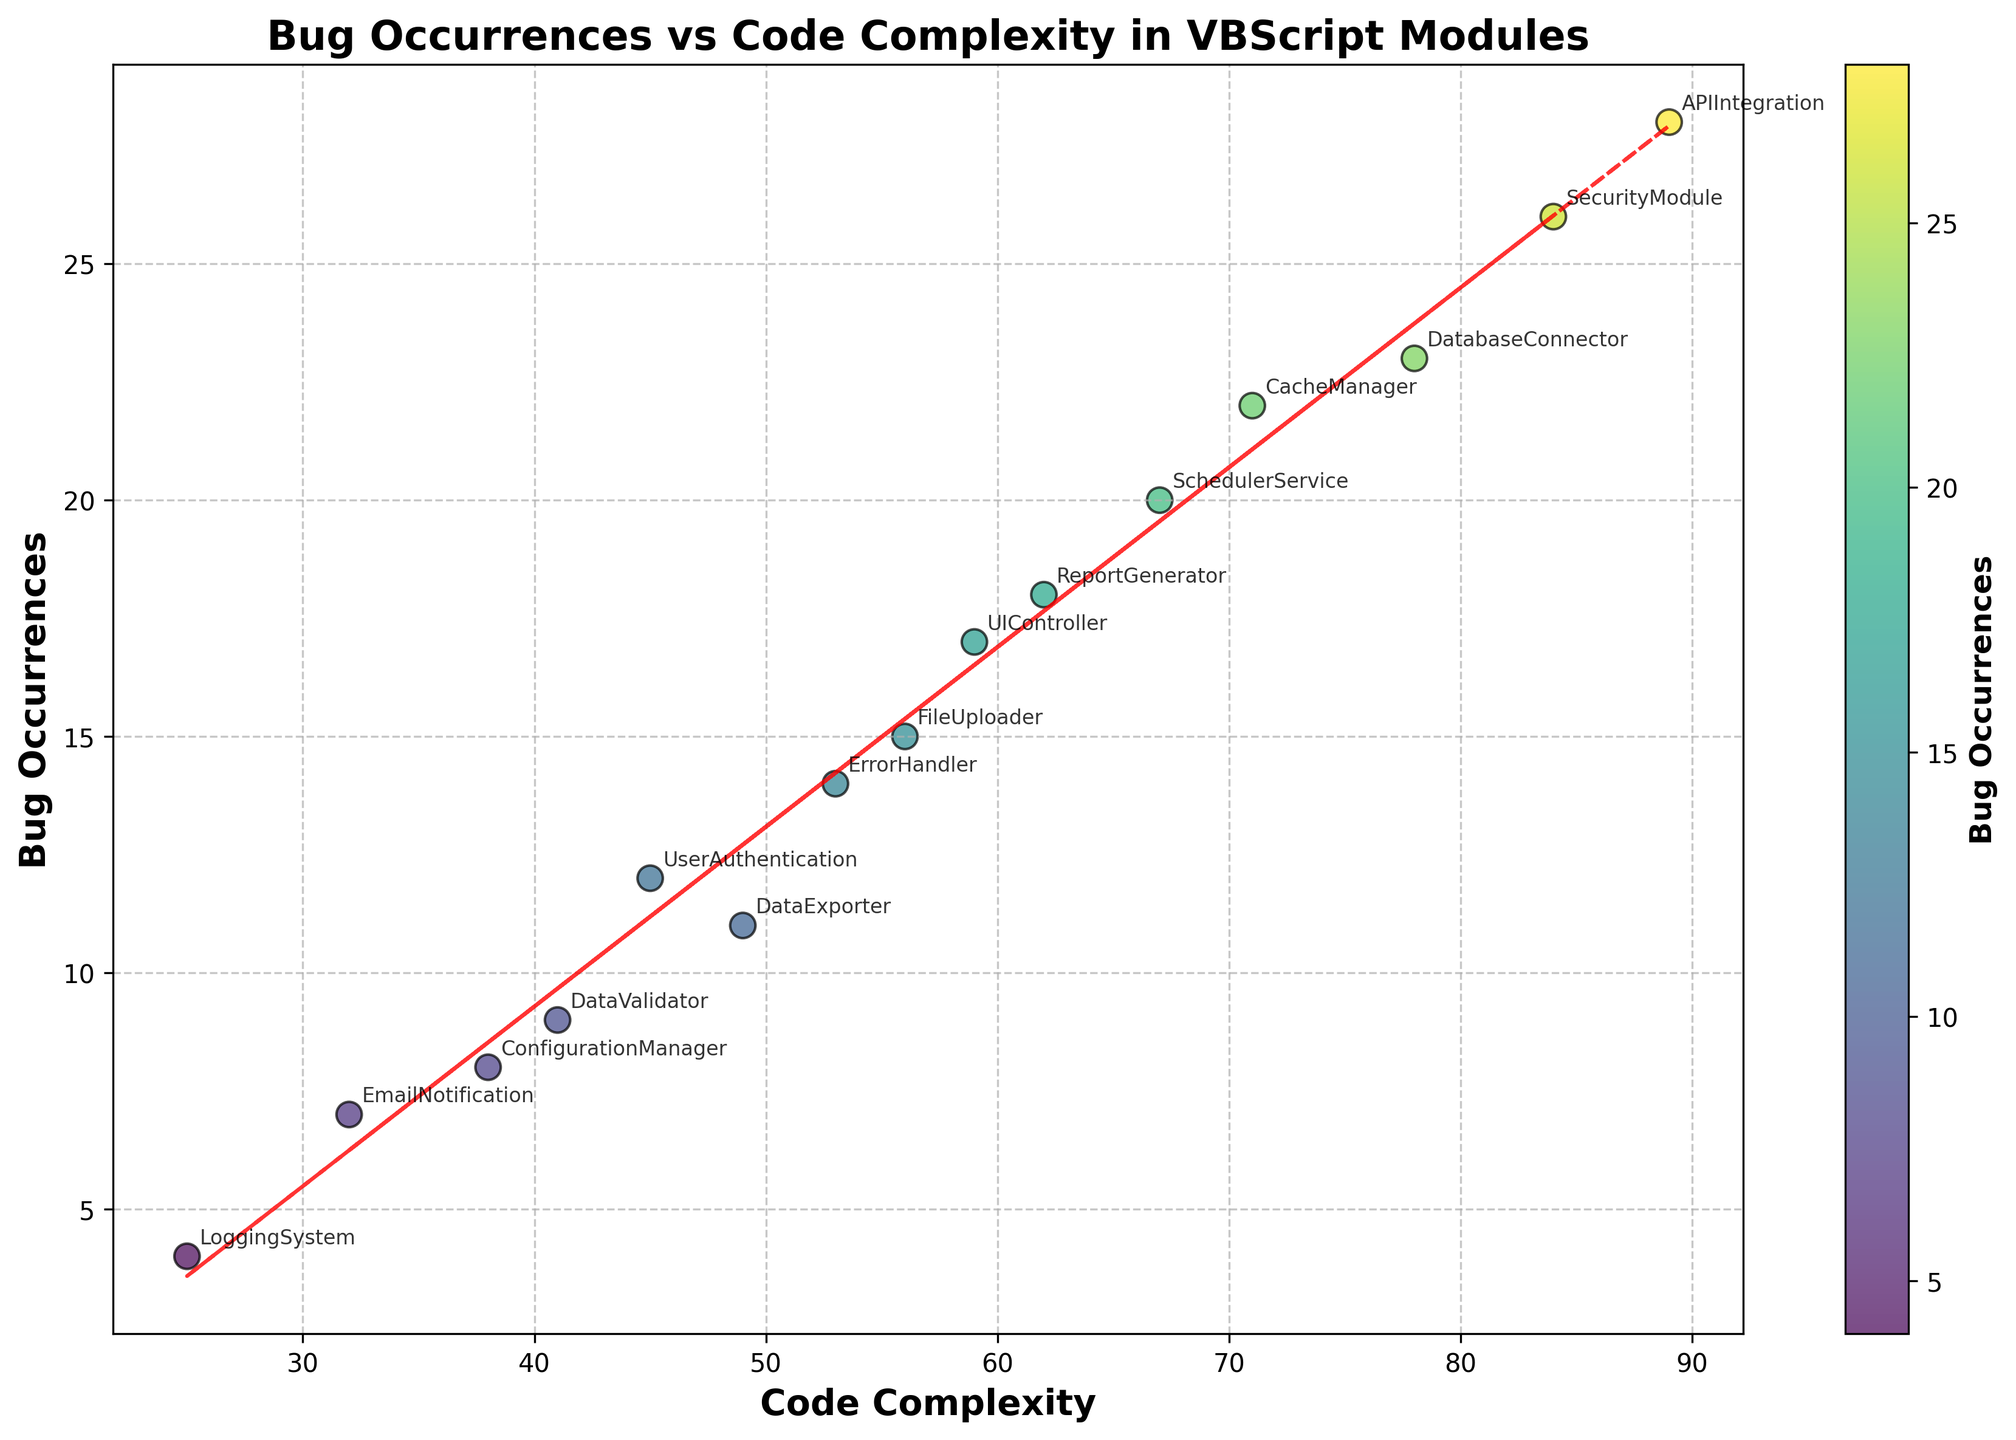What is the title of the plot? The title is prominently displayed at the top of the plot in bold text. It reads, "Bug Occurrences vs Code Complexity in VBScript Modules".
Answer: Bug Occurrences vs Code Complexity in VBScript Modules What are the labels of the X and Y axes? The labels for the axes are indicated in bold text. The X-axis is labeled "Code Complexity" and the Y-axis is labeled "Bug Occurrences".
Answer: Code Complexity (X-axis), Bug Occurrences (Y-axis) How many data points represent the different modules? By counting the number of scatter points along with the annotations for each module, we see that there are 15 data points.
Answer: 15 Which module shows the highest number of bug occurrences? The scatter point at the topmost position on the Y-axis represents the 'APIIntegration' module with 28 bug occurrences.
Answer: APIIntegration What is the code complexity of the 'ReportGenerator' module? Looking at the specific annotation for 'ReportGenerator', its position along the X-axis indicates a code complexity value of 62.
Answer: 62 Which two modules have the closest bug occurrences, and what are those values? By closely inspecting the values of bug occurrences, we see 'CachingManager' and 'SchedulerService' are close with 22 and 20 bug occurrences, respectively.
Answer: CacheManager (22), SchedulerService (20) What is the trend line's overall direction? The scatter plot includes a red dashed trend line, which slopes upwards from left to right, indicating a positive correlation between code complexity and bug occurrences.
Answer: Positive correlation What is the difference in bug occurrences between 'UserAuthentication' and 'SecurityModule'? 'UserAuthentication' has 12 bug occurrences and 'SecurityModule' has 26. The difference is 26 - 12 = 14.
Answer: 14 Which module identifies the least number of bug occurrences and what is its code complexity? 'LoggingSystem' is at the lowest position on the Y-axis with 4 bug occurrences and a code complexity of 25.
Answer: LoggingSystem (4 bug occurrences, code complexity 25) Is there a module with a code complexity in the 30s and what are its bug occurrences? 'ConfigurationManager' falls within the 30s in code complexity at 38, with 8 bug occurrences.
Answer: ConfigurationManager (code complexity 38, bug occurrences 8) 